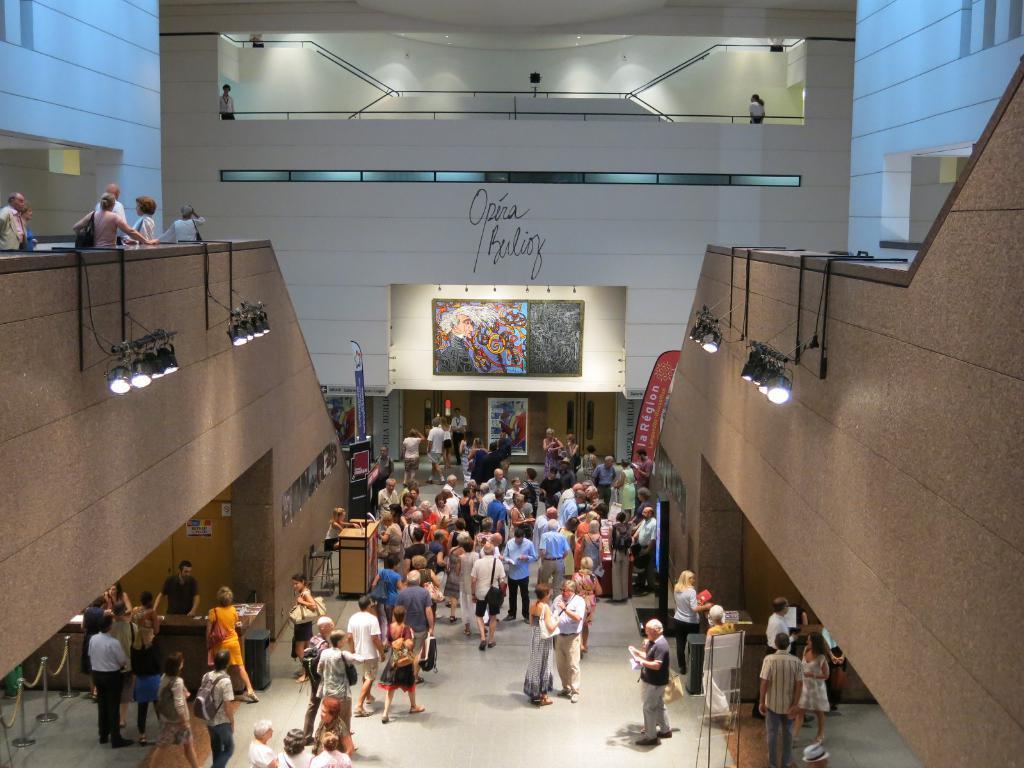Please provide a concise description of this image. In this image we can see people standing on the floor and some are standing behind the tables. In the background we can see building, railings, people standing on the stairs, electric lights, advertisement boards and a screen. 